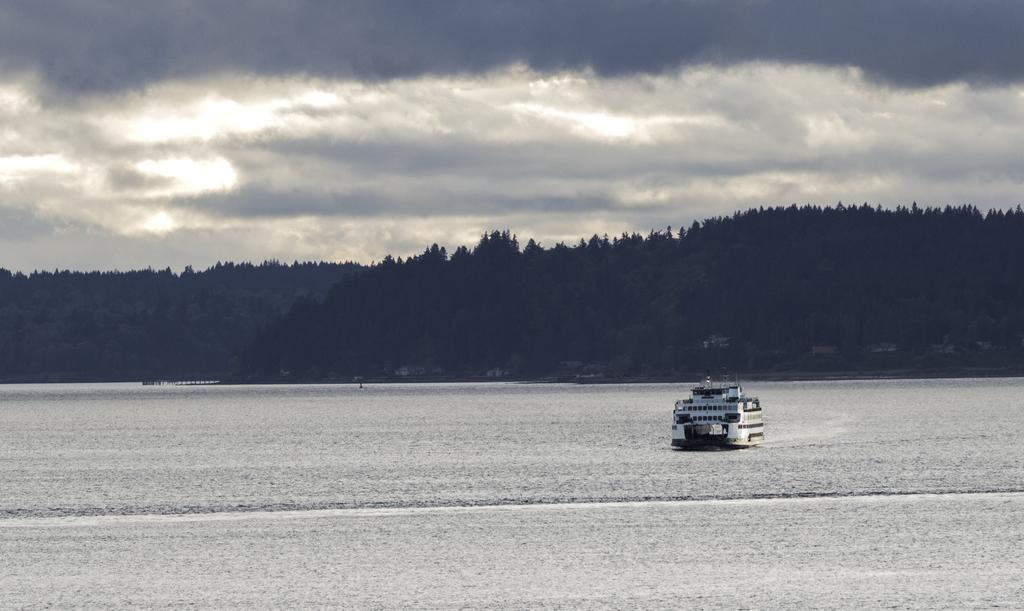What is the weather like in the image? The sky in the image is cloudy. What type of natural vegetation can be seen in the image? There are trees visible in the image. What is located in the water in the image? There is a ship in the water in the image. How many bats are hanging from the ship in the image? There are no bats present in the image; it features a ship in the water with a cloudy sky and trees. What type of blade is being used to cut the clam in the image? There is no clam or blade present in the image. 